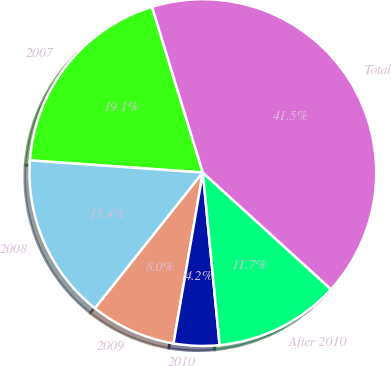<chart> <loc_0><loc_0><loc_500><loc_500><pie_chart><fcel>2007<fcel>2008<fcel>2009<fcel>2010<fcel>After 2010<fcel>Total<nl><fcel>19.15%<fcel>15.43%<fcel>7.98%<fcel>4.25%<fcel>11.7%<fcel>41.49%<nl></chart> 